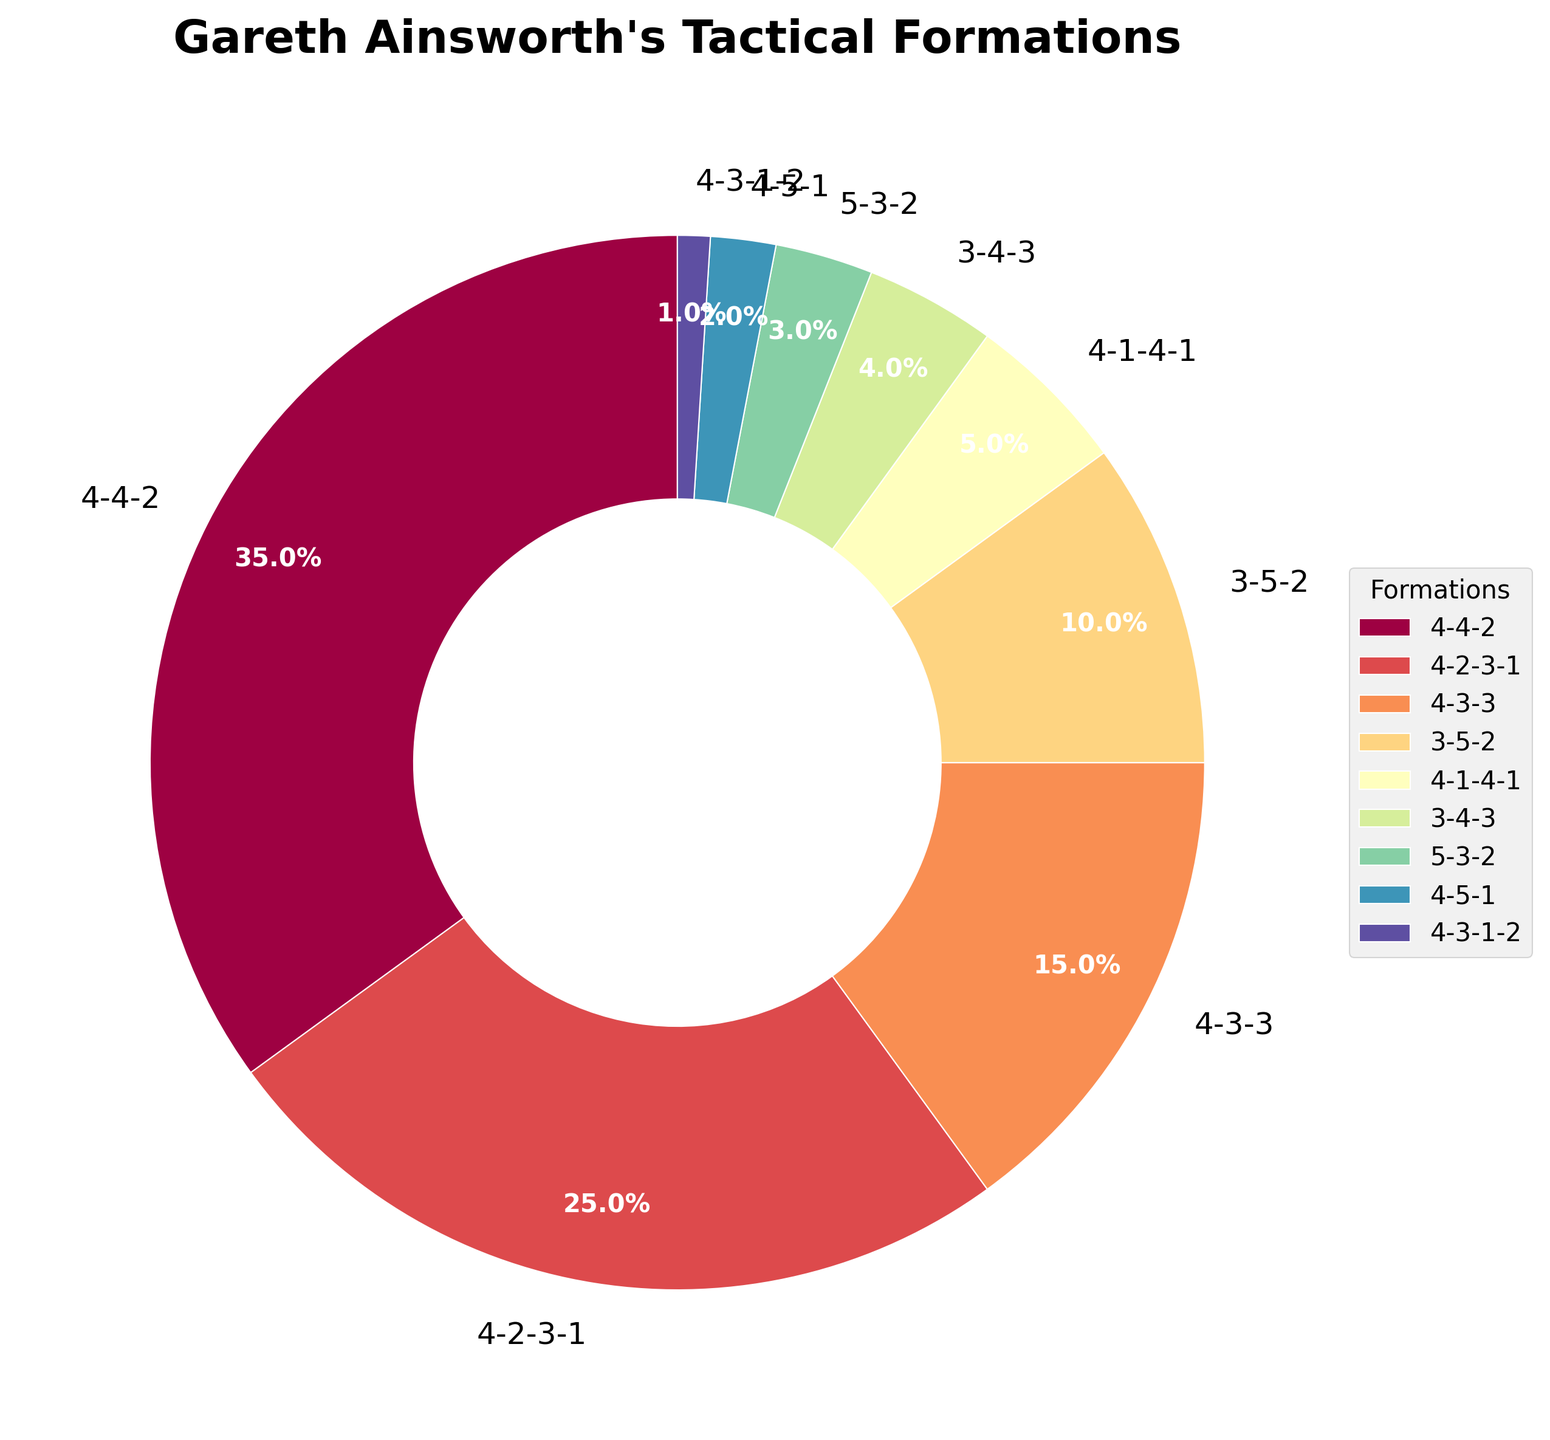Which formation has the highest percentage in the pie chart? The pie chart shows the breakdown of Gareth Ainsworth's tactical formations. The largest section of the pie chart represents the formation with the highest percentage.
Answer: 4-4-2 What is the combined percentage of the formations 4-2-3-1 and 3-5-2? To find the combined percentage, add the percentages of both formations: 4-2-3-1 is 25% and 3-5-2 is 10%, giving a total of 25% + 10% = 35%.
Answer: 35% How many formations have a percentage lower than 5%? From the pie chart, identify the sections that represent formations with percentages less than 5%. Those formations are 4-1-4-1 (5%), 3-4-3 (4%), 5-3-2 (3%), 4-5-1 (2%), and 4-3-1-2 (1%). Count these formations.
Answer: 4 Which formation represents the smallest section in the pie chart? The smallest section will be the one with the lowest percentage, which can be identified as 4-3-1-2 with a percentage of 1%.
Answer: 4-3-1-2 Is the percentage of the 4-4-2 formation greater than the sum of 4-3-3 and 3-5-2 formations? First, find the percentage of the 4-4-2 formation (35%). Then, add the percentages of the 4-3-3 (15%) and 3-5-2 (10%) formations. The sum is 15% + 10% = 25%. Compare 35% and 25% to see which is greater.
Answer: Yes What is the average percentage of the formations 4-4-2, 4-2-3-1, and 4-3-3? To find the average percentage, add the percentages of the 4-4-2 (35%), 4-2-3-1 (25%), and 4-3-3 (15%) formations, and then divide by the number of formations: (35% + 25% + 15%) / 3 = 75% / 3.
Answer: 25% Which color is used to represent the 4-2-3-1 formation in the pie chart? Visual inspection of the pie chart will show that the 4-2-3-1 formation has its own distinct color. Identify this color.
Answer: Purple Does the percentage of the 4-4-2 formation exceed the percentage of all formations combined that have less than 10%? First, add up the percentages of all formations with less than 10% which are 3-5-2 (10%), 4-1-4-1 (5%), 3-4-3 (4%), 5-3-2 (3%), 4-5-1 (2%), 4-3-1-2 (1%). This sums to 10% + 5% + 4% + 3% + 2% + 1% = 25%. Compare this with the 4-4-2 (35%) percentage.
Answer: Yes 